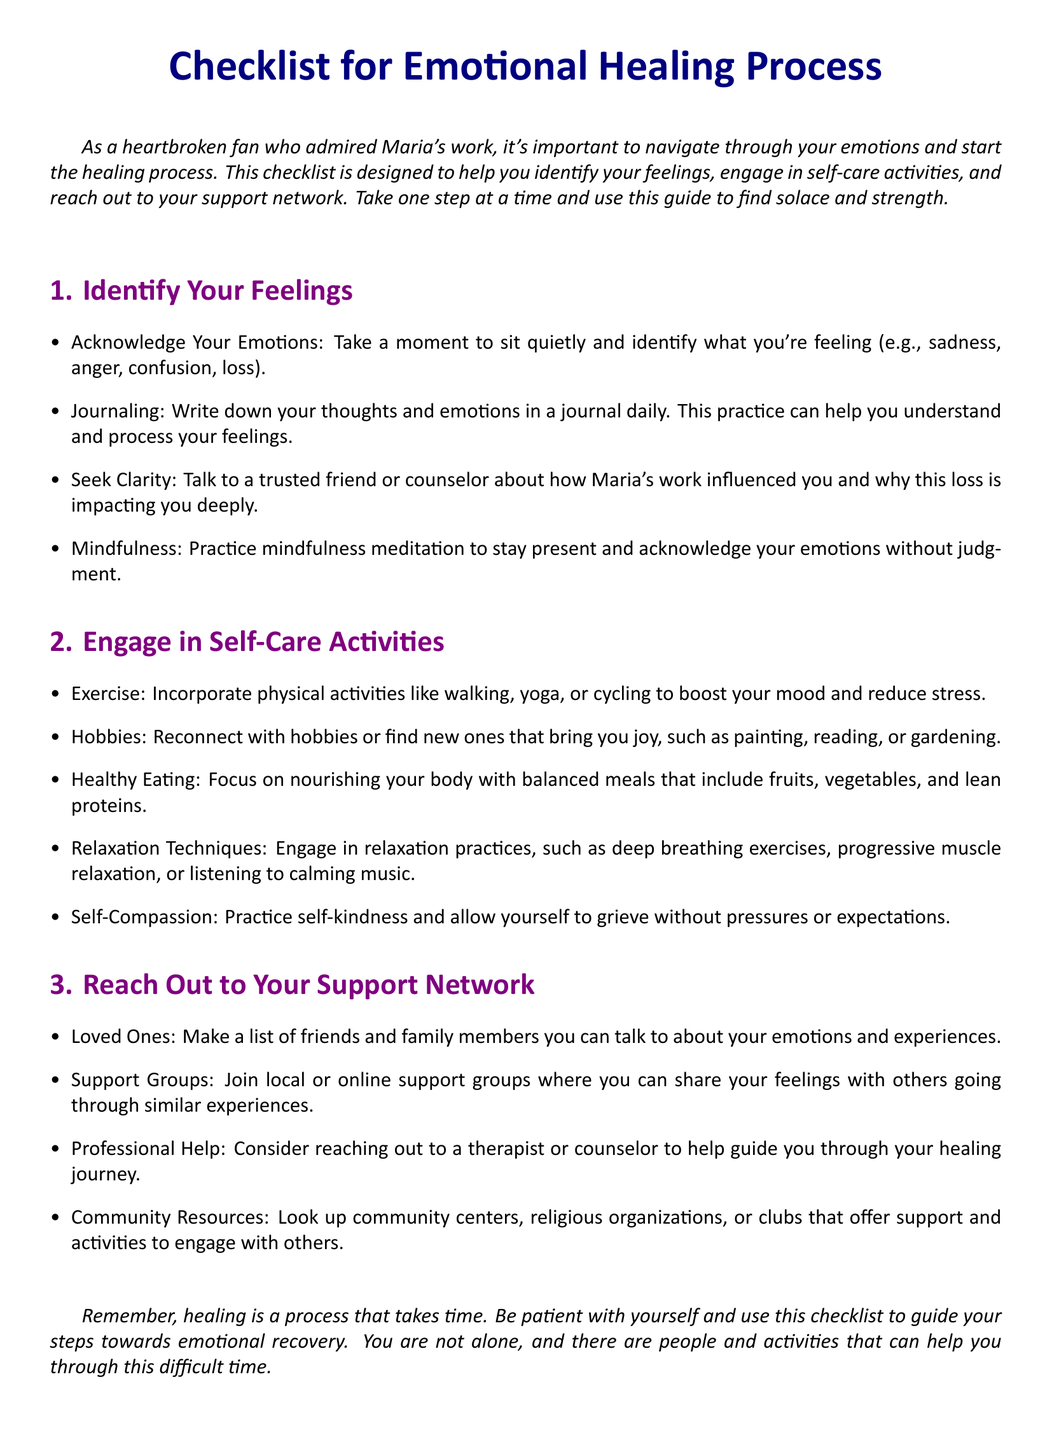What is the title of the checklist? The title of the checklist is presented prominently at the start of the document.
Answer: Checklist for Emotional Healing Process How many sections are in the checklist? The checklist contains three distinct sections outlined clearly.
Answer: 3 What activity is suggested for engaging in self-care? The document lists various activities under self-care, specifically mentioning exercise.
Answer: Exercise What is the first item listed under identifying feelings? The first item focuses on understanding one's emotional state and acknowledging it.
Answer: Acknowledge Your Emotions Name a method recommended for reaching out to your support network. A method mentioned in the document involves connecting with friends or family for support.
Answer: Loved Ones Which mindfulness practice is suggested in the checklist? The checklist encourages practicing mindfulness meditation as a way to cope with emotions.
Answer: Mindfulness What should you do to practice self-compassion according to the checklist? The document advises engaging in self-kindness and allowing oneself to grieve.
Answer: Practice self-kindness What is recommended for healthy eating? Healthy eating recommendations focus on nourishing the body with balanced meals.
Answer: Balanced meals Which professional help is suggested for emotional healing? The checklist mentions considering reaching out to a therapist or counselor for support.
Answer: Therapist or counselor 